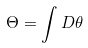<formula> <loc_0><loc_0><loc_500><loc_500>\Theta = \int D \theta</formula> 